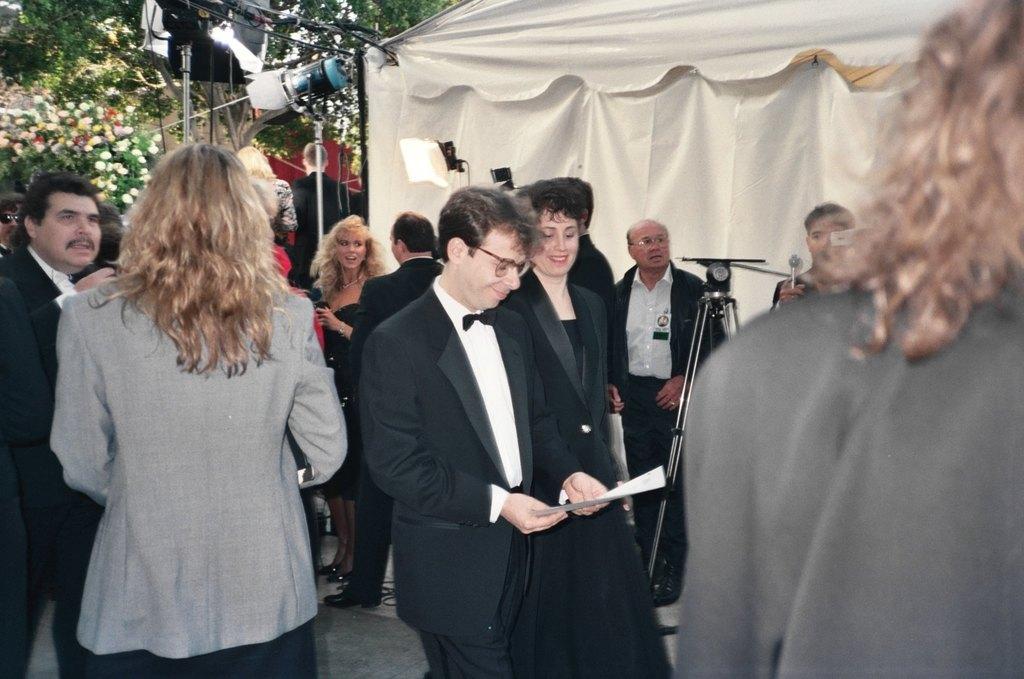Please provide a concise description of this image. In this image there are group of people standing on the floor. In the middle there is a man who is wearing the suit and holding the paper. In the background there is a tent. Beside the text there are lights. In the background there are flower plants and trees. 